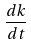<formula> <loc_0><loc_0><loc_500><loc_500>\frac { d k } { d t }</formula> 